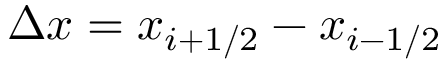<formula> <loc_0><loc_0><loc_500><loc_500>\Delta x = x _ { i + 1 / 2 } - x _ { i - 1 / 2 }</formula> 